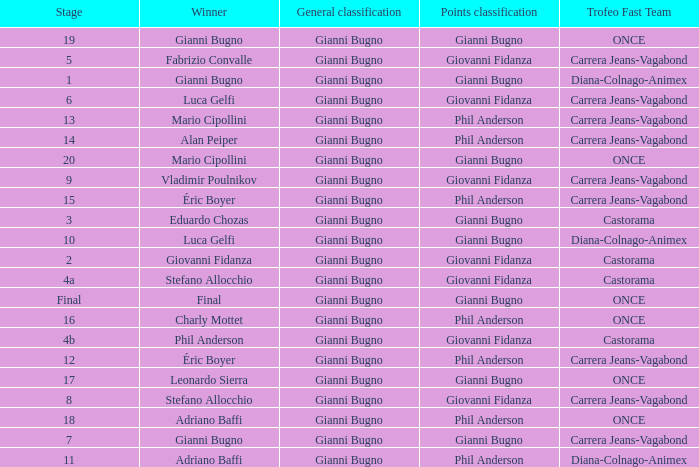Who was the trofeo fast team in stage 10? Diana-Colnago-Animex. Parse the full table. {'header': ['Stage', 'Winner', 'General classification', 'Points classification', 'Trofeo Fast Team'], 'rows': [['19', 'Gianni Bugno', 'Gianni Bugno', 'Gianni Bugno', 'ONCE'], ['5', 'Fabrizio Convalle', 'Gianni Bugno', 'Giovanni Fidanza', 'Carrera Jeans-Vagabond'], ['1', 'Gianni Bugno', 'Gianni Bugno', 'Gianni Bugno', 'Diana-Colnago-Animex'], ['6', 'Luca Gelfi', 'Gianni Bugno', 'Giovanni Fidanza', 'Carrera Jeans-Vagabond'], ['13', 'Mario Cipollini', 'Gianni Bugno', 'Phil Anderson', 'Carrera Jeans-Vagabond'], ['14', 'Alan Peiper', 'Gianni Bugno', 'Phil Anderson', 'Carrera Jeans-Vagabond'], ['20', 'Mario Cipollini', 'Gianni Bugno', 'Gianni Bugno', 'ONCE'], ['9', 'Vladimir Poulnikov', 'Gianni Bugno', 'Giovanni Fidanza', 'Carrera Jeans-Vagabond'], ['15', 'Éric Boyer', 'Gianni Bugno', 'Phil Anderson', 'Carrera Jeans-Vagabond'], ['3', 'Eduardo Chozas', 'Gianni Bugno', 'Gianni Bugno', 'Castorama'], ['10', 'Luca Gelfi', 'Gianni Bugno', 'Gianni Bugno', 'Diana-Colnago-Animex'], ['2', 'Giovanni Fidanza', 'Gianni Bugno', 'Giovanni Fidanza', 'Castorama'], ['4a', 'Stefano Allocchio', 'Gianni Bugno', 'Giovanni Fidanza', 'Castorama'], ['Final', 'Final', 'Gianni Bugno', 'Gianni Bugno', 'ONCE'], ['16', 'Charly Mottet', 'Gianni Bugno', 'Phil Anderson', 'ONCE'], ['4b', 'Phil Anderson', 'Gianni Bugno', 'Giovanni Fidanza', 'Castorama'], ['12', 'Éric Boyer', 'Gianni Bugno', 'Phil Anderson', 'Carrera Jeans-Vagabond'], ['17', 'Leonardo Sierra', 'Gianni Bugno', 'Gianni Bugno', 'ONCE'], ['8', 'Stefano Allocchio', 'Gianni Bugno', 'Giovanni Fidanza', 'Carrera Jeans-Vagabond'], ['18', 'Adriano Baffi', 'Gianni Bugno', 'Phil Anderson', 'ONCE'], ['7', 'Gianni Bugno', 'Gianni Bugno', 'Gianni Bugno', 'Carrera Jeans-Vagabond'], ['11', 'Adriano Baffi', 'Gianni Bugno', 'Phil Anderson', 'Diana-Colnago-Animex']]} 